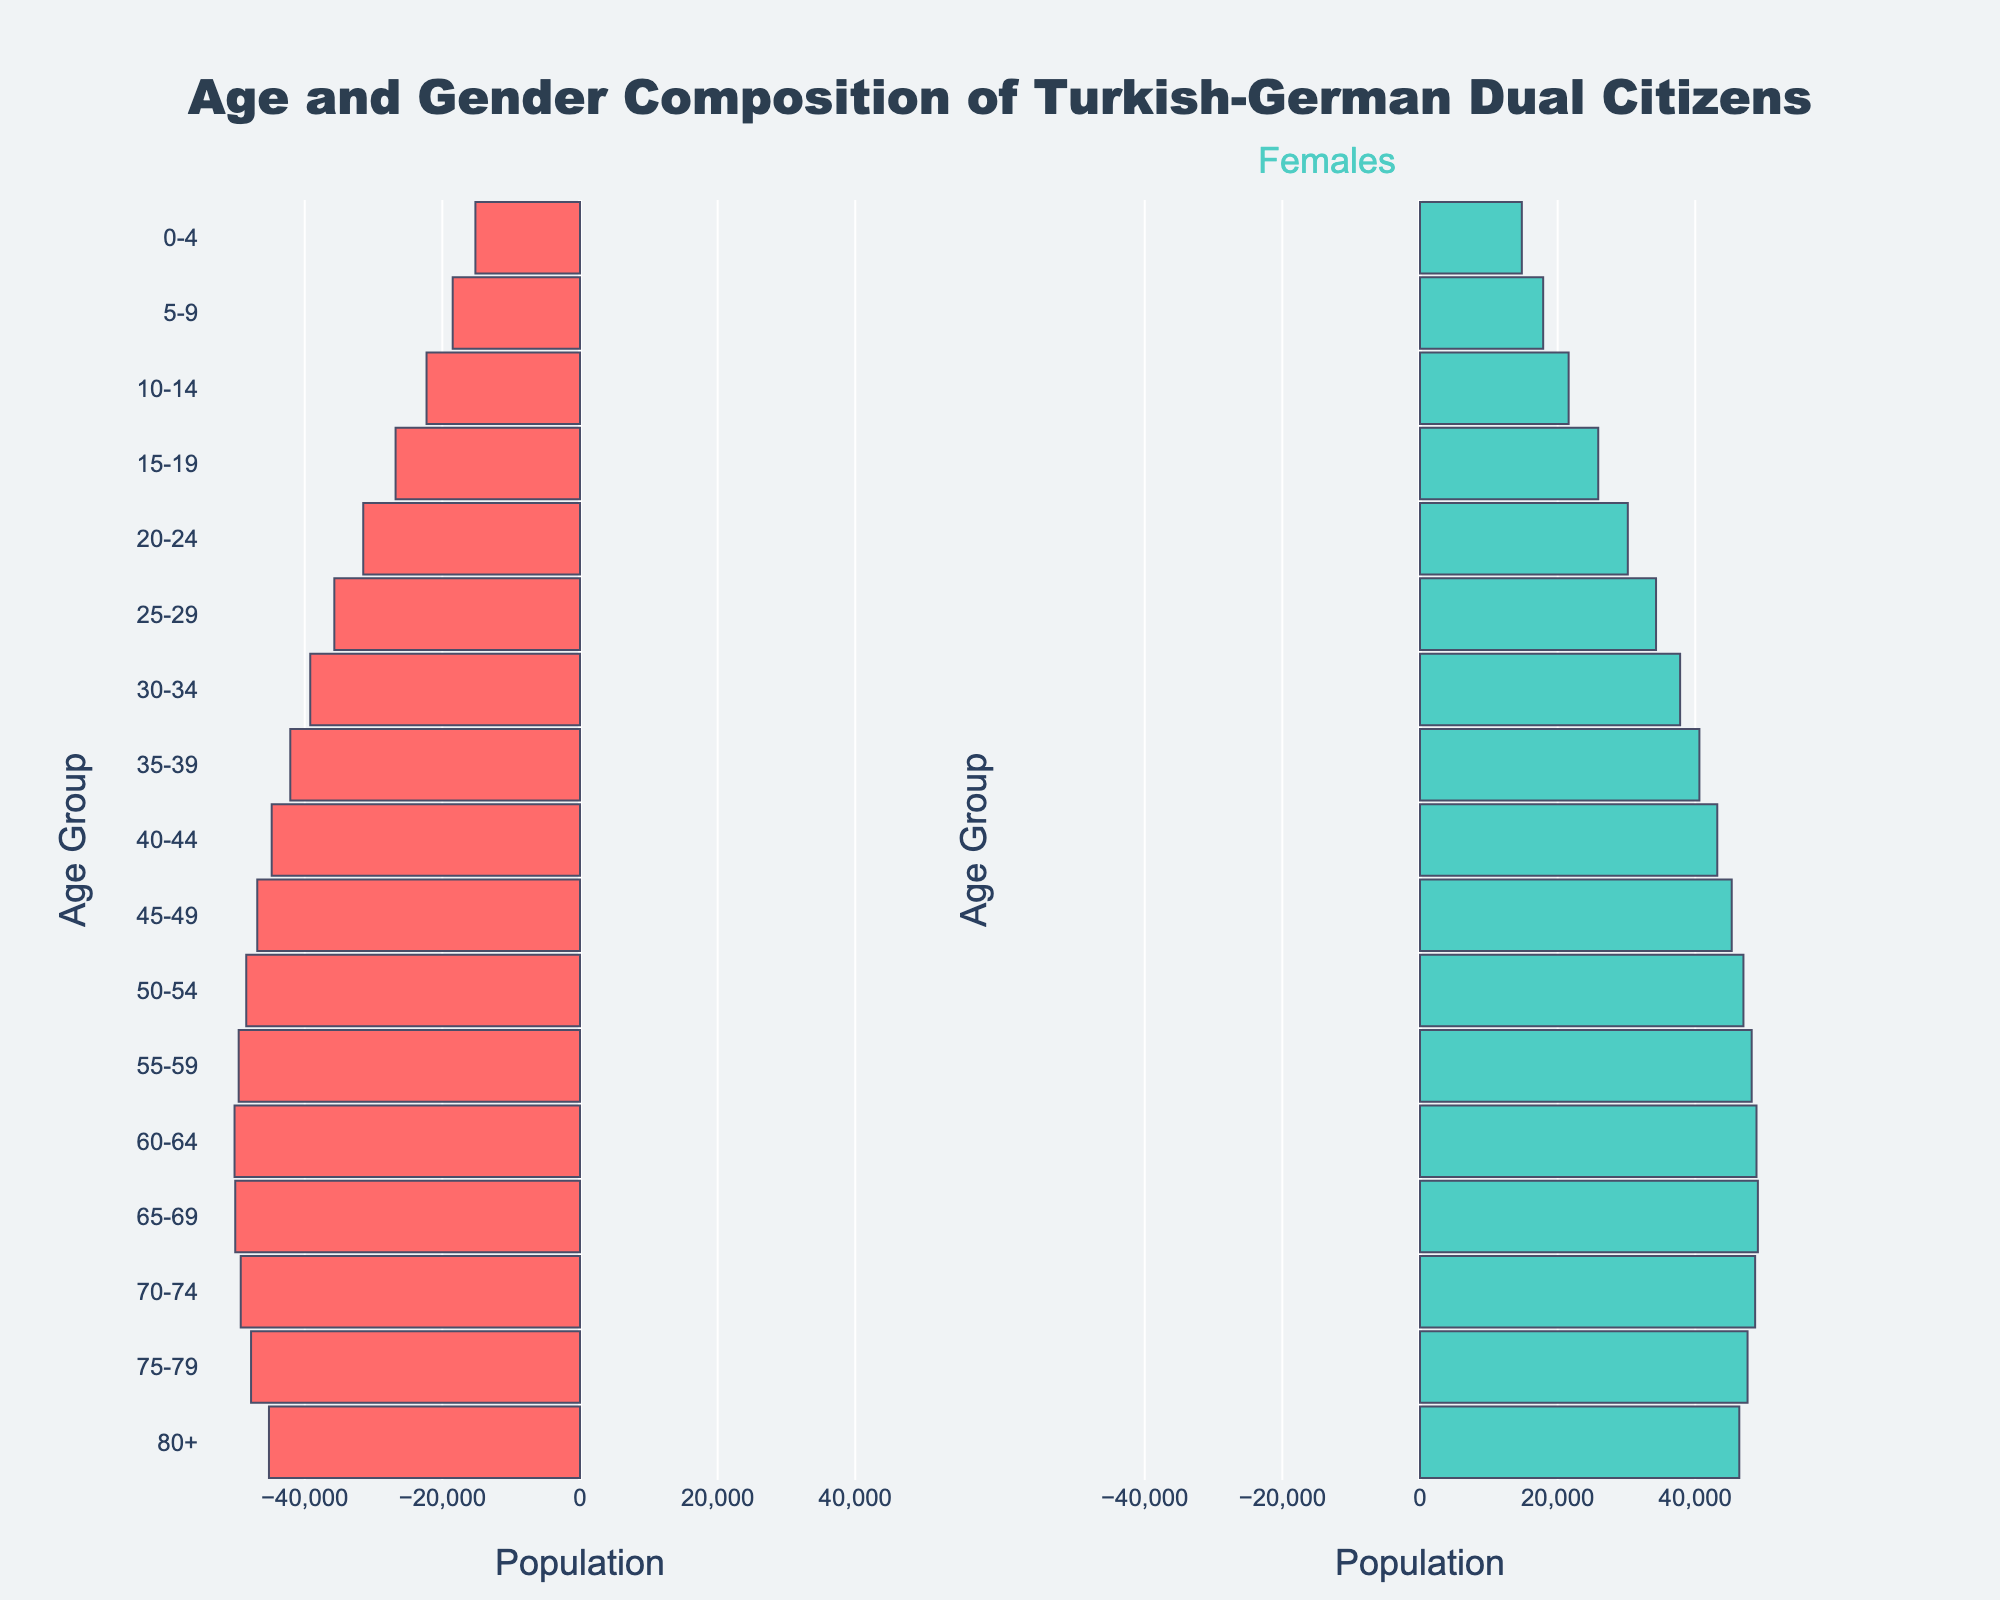What is the title of the figure? The title is written at the top of the chart and provides an overview of the data being presented.
Answer: Age and Gender Composition of Turkish-German Dual Citizens What color represents males in the population pyramid? The colors can be found from the male and female bar sections within the pyramid. Check the figure legend or the bar colors themselves.
Answer: Red Which age group has the highest number of females? Find the age group with the longest bar on the female side.
Answer: 60-64 What is the population of males in the age group 75-79? Look at the length of the bar corresponding to males in the 75-79 age group and refer to the axis values.
Answer: 47800 How does the female population in the 20-24 age group compare to the male population in the same age group? Compare the length of the bars for both genders in the 20-24 age group.
Answer: The female population is less than the male population Which age group has the smallest gender difference in population? Calculate the absolute difference between males and females for all age groups and identify the smallest value.
Answer: 65-69 In which age groups do females outnumber males? Identify age groups where the female bars are longer than male bars.
Answer: 80+ How many more males are there in the 30-34 age group compared to females? Subtract the number of females from the number of males in the 30-34 age group.
Answer: 1400 Which age group has the steepest decline in male population compared to the previous age group? Calculate the difference in male population between consecutive age groups and identify the largest negative difference.
Answer: 80+ What is the total population of Turkish-German dual citizens in this dataset? Sum up the populations of males and females across all age groups.
Answer: 831500 